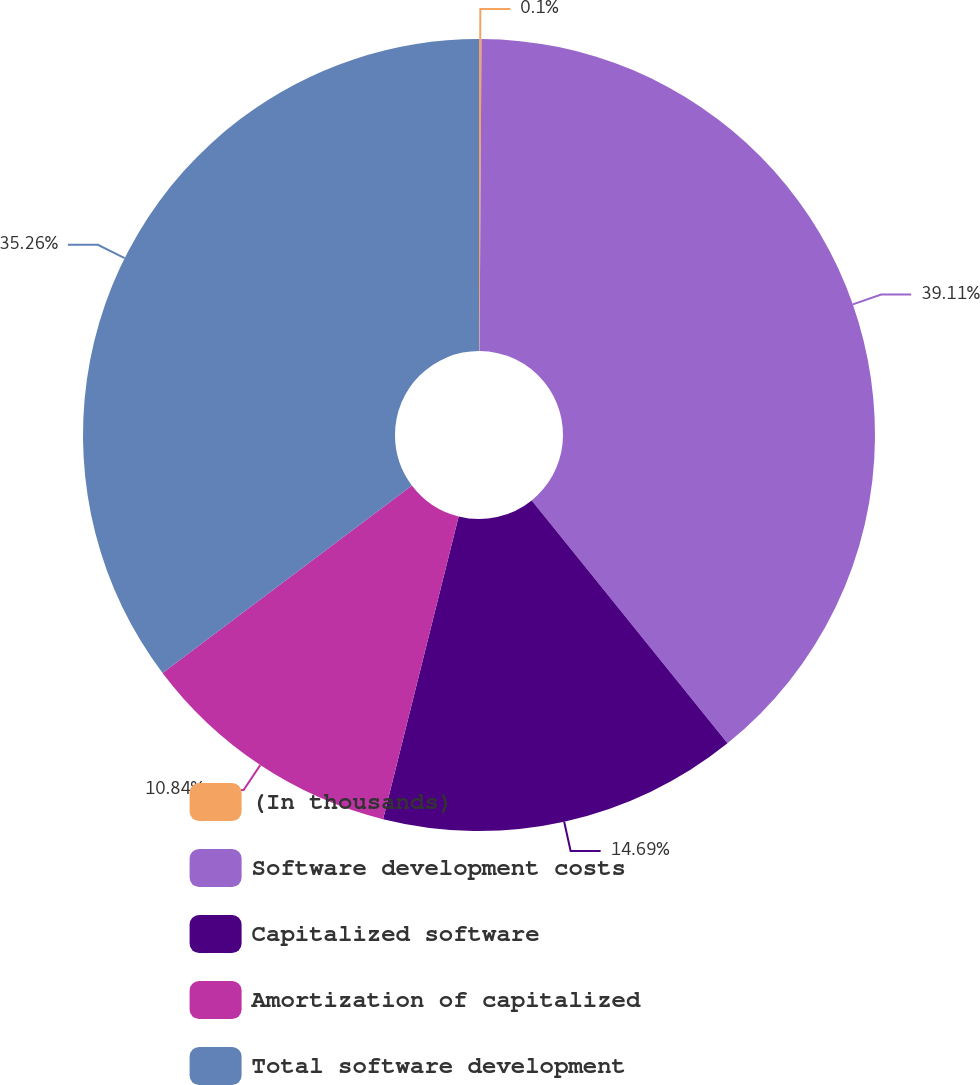Convert chart to OTSL. <chart><loc_0><loc_0><loc_500><loc_500><pie_chart><fcel>(In thousands)<fcel>Software development costs<fcel>Capitalized software<fcel>Amortization of capitalized<fcel>Total software development<nl><fcel>0.1%<fcel>39.1%<fcel>14.69%<fcel>10.84%<fcel>35.26%<nl></chart> 